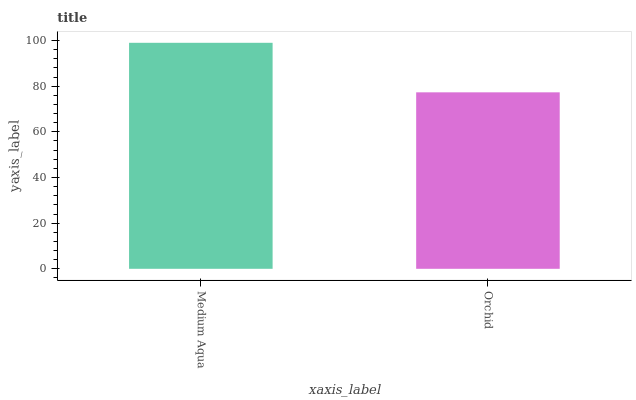Is Orchid the minimum?
Answer yes or no. Yes. Is Medium Aqua the maximum?
Answer yes or no. Yes. Is Orchid the maximum?
Answer yes or no. No. Is Medium Aqua greater than Orchid?
Answer yes or no. Yes. Is Orchid less than Medium Aqua?
Answer yes or no. Yes. Is Orchid greater than Medium Aqua?
Answer yes or no. No. Is Medium Aqua less than Orchid?
Answer yes or no. No. Is Medium Aqua the high median?
Answer yes or no. Yes. Is Orchid the low median?
Answer yes or no. Yes. Is Orchid the high median?
Answer yes or no. No. Is Medium Aqua the low median?
Answer yes or no. No. 